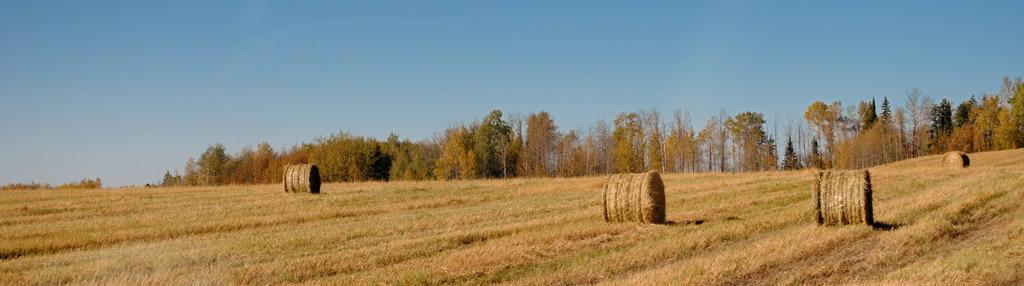How would you summarize this image in a sentence or two? In the picture I can see some farmlands, there are some trees, top of the picture there is clear sky. 